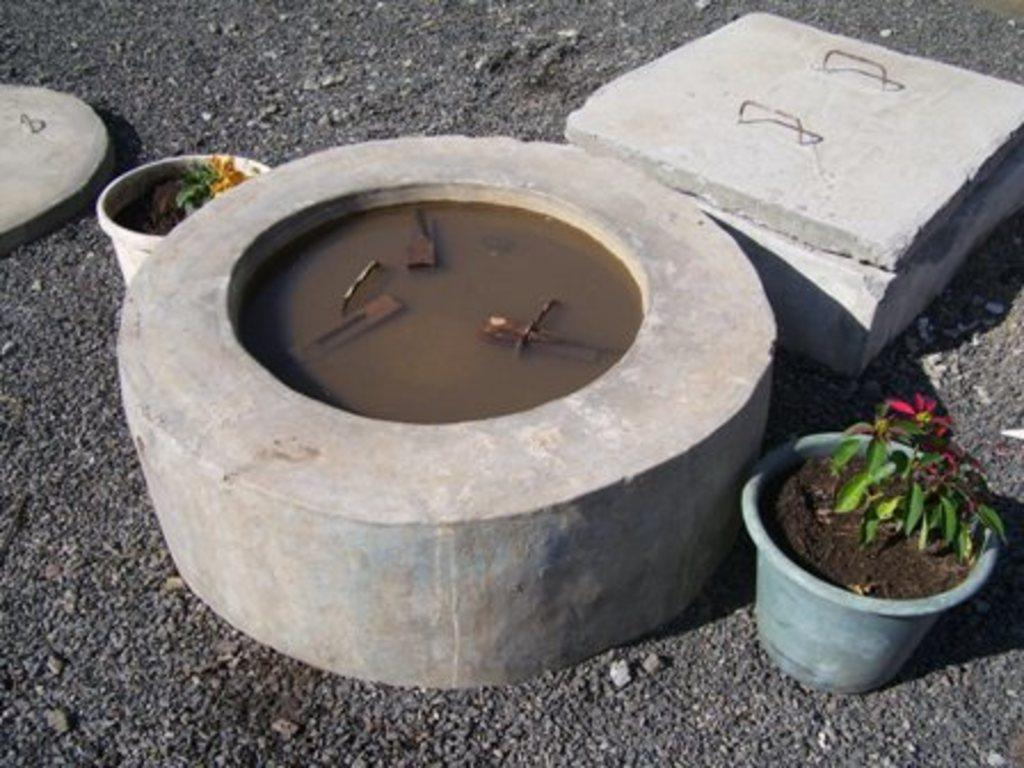What type of objects can be seen in the image? There are plant pots and solid objects in the image. Can you describe the circular object in the image? There is a solid circular object in the image, and it contains water. What type of surface is visible in the image? There is a road visible in the image. What sound can be heard coming from the cup in the image? There is no cup present in the image, so no sound can be heard coming from it. 